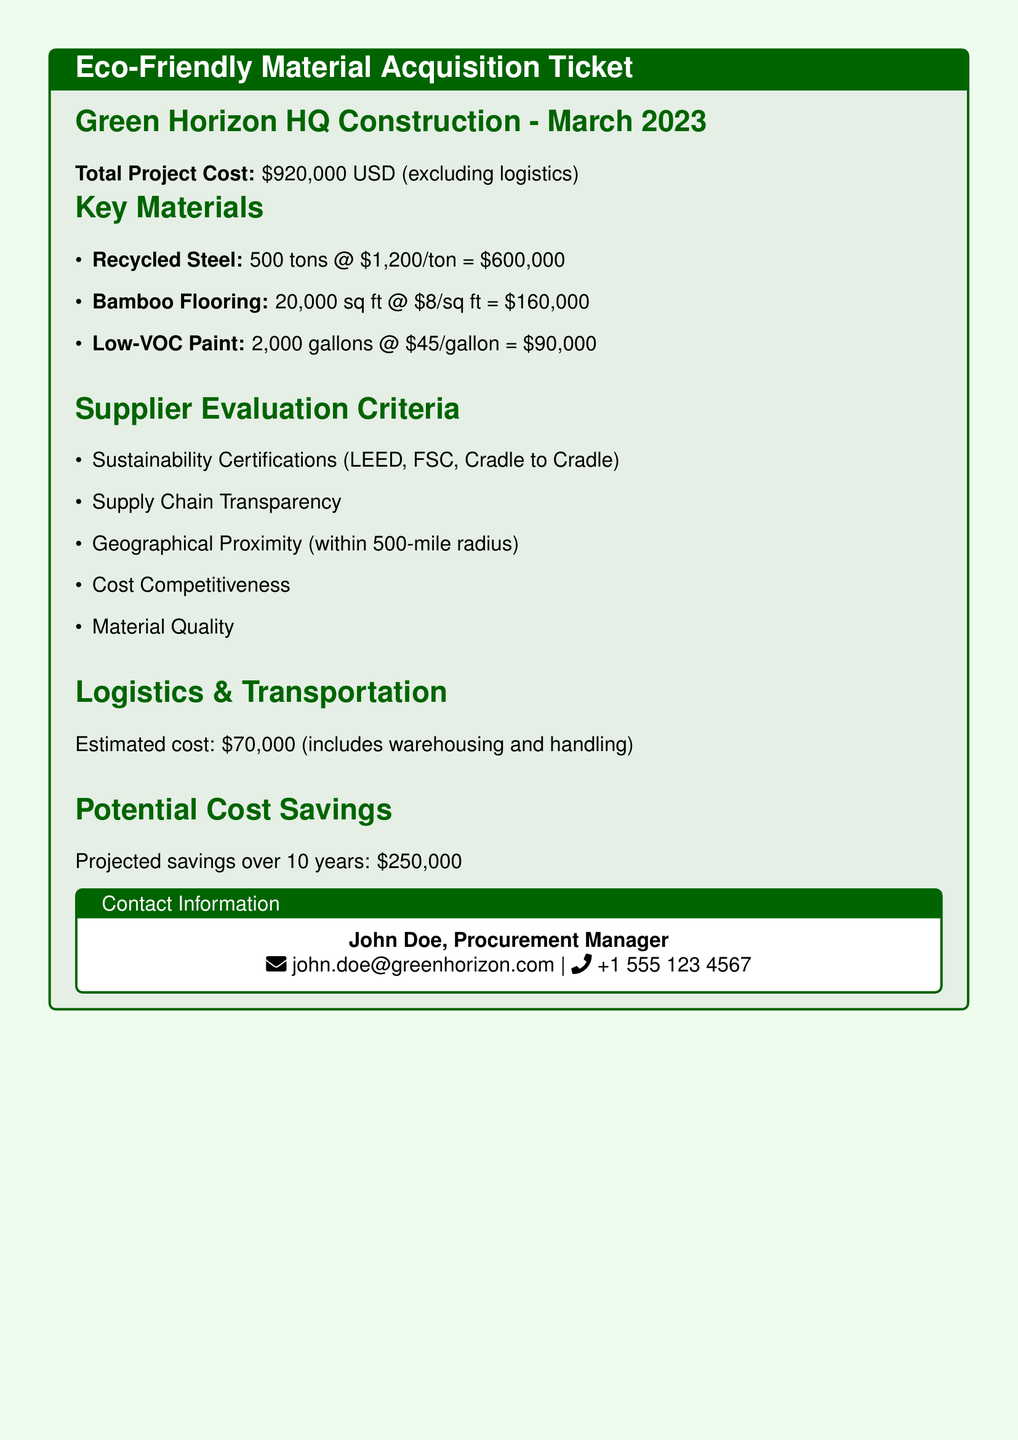what is the total project cost? The total project cost is explicitly mentioned in the document as $920,000, which encompasses all expenditures except logistics.
Answer: $920,000 how much does recycled steel cost per ton? The document specifies the cost of recycled steel, which is stated to be $1,200 per ton.
Answer: $1,200 what is the quantity of bamboo flooring required? The required quantity of bamboo flooring is given in the document as 20,000 square feet.
Answer: 20,000 sq ft what are the sustainability certifications mentioned? The document lists sustainability certifications as LEED, FSC, and Cradle to Cradle, highlighting their importance in supplier selection.
Answer: LEED, FSC, Cradle to Cradle what is the estimated logistics and transportation cost? The estimated logistics and transportation cost is outlined in the document as $70,000, which includes warehousing and handling expenses.
Answer: $70,000 how much is projected savings over 10 years? The document indicates that the projected savings over 10 years are estimated to be $250,000, showcasing the financial benefits of eco-friendly materials.
Answer: $250,000 which material accounts for the highest cost in the project? By analyzing the costs of the key materials listed, recycled steel, costing $600,000, stands out as the most expensive material for the project.
Answer: Recycled Steel what is the role of John Doe in the project? The document identifies John Doe as the Procurement Manager, suggesting his responsibility for sourcing and material acquisition.
Answer: Procurement Manager within what radius should suppliers be located? The document states that suppliers should be geographically proximate, specifically within a 500-mile radius, ensuring logistics convenience.
Answer: 500-mile radius 